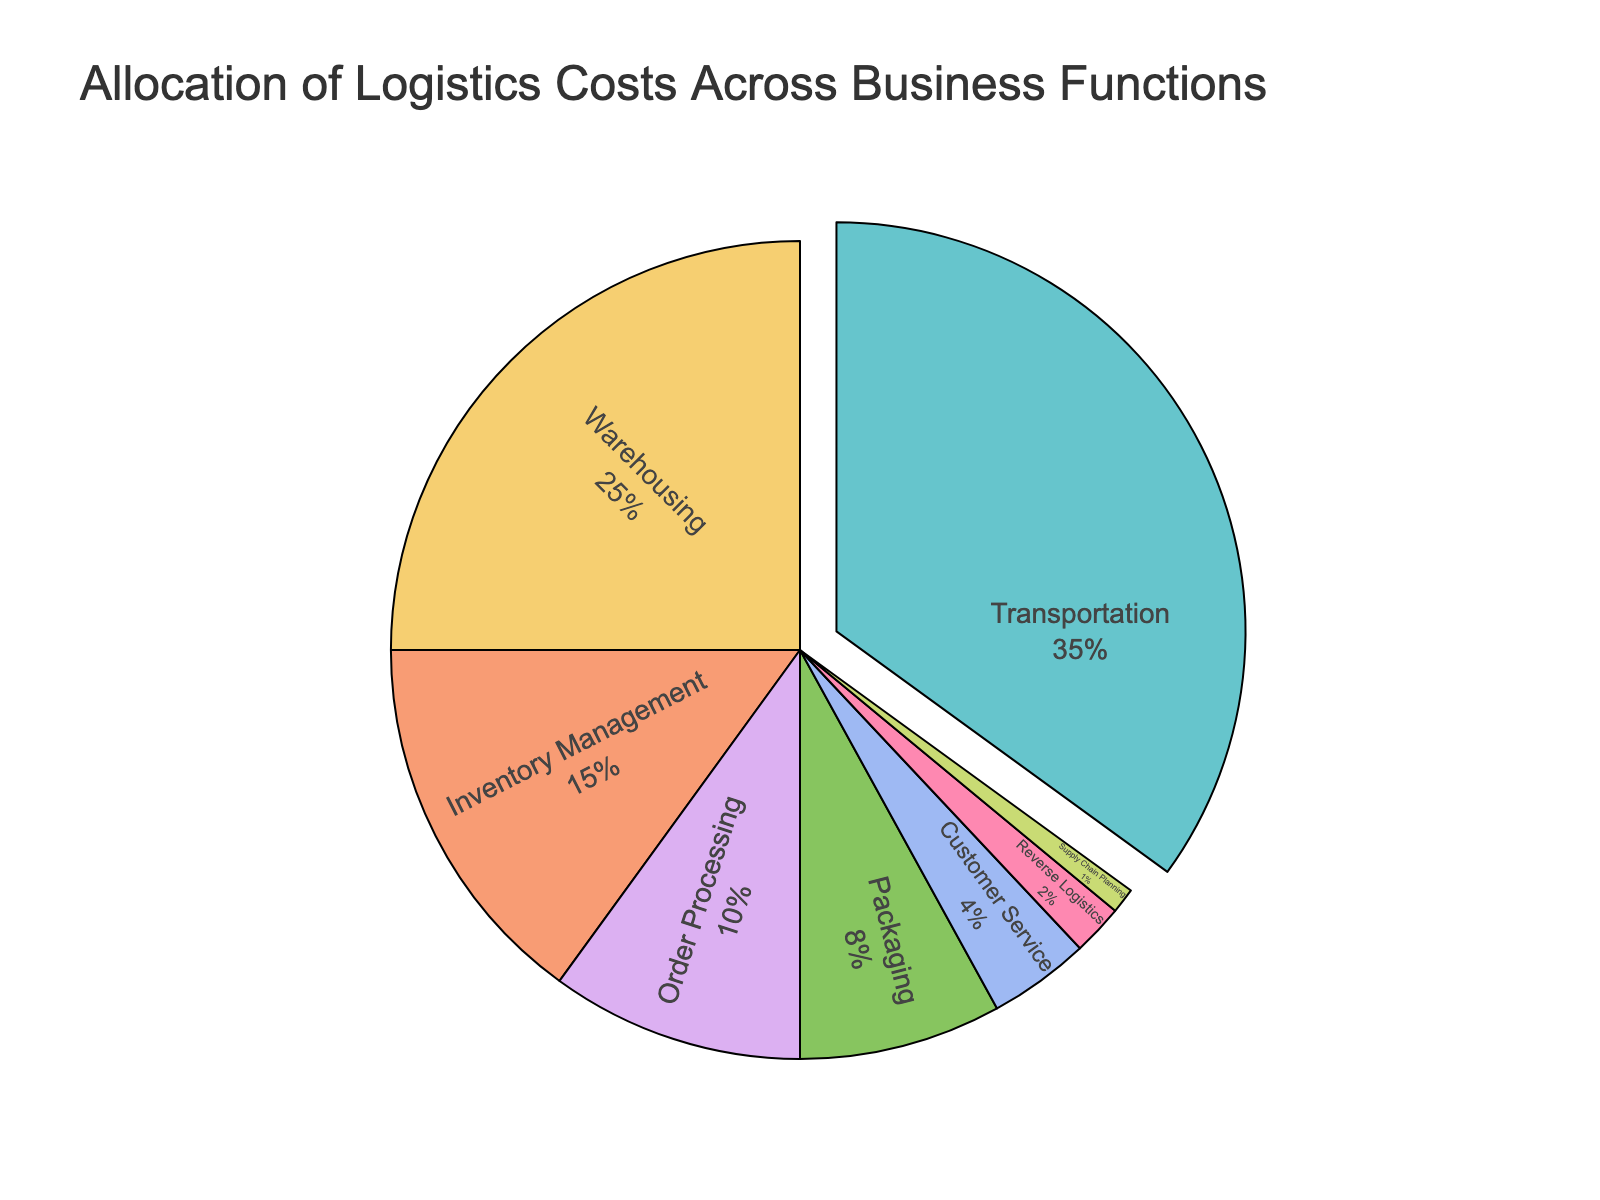What percentage of the total logistics costs is allocated to both Warehousing and Packaging combined? To determine the combined percentage of Warehousing and Packaging, add the individual percentages: Warehousing (25%) + Packaging (8%) = 33%
Answer: 33% Which business function has the highest allocation of logistics costs? By observing the slices of the pie chart, Transportation stands out as it has the largest slice, marked with some separation from the rest. The percentage for Transportation is 35%, which is higher than any other function.
Answer: Transportation How much greater is the cost allocation for Customer Service compared to Reverse Logistics? The cost allocation for Customer Service is 4% and for Reverse Logistics is 2%. The difference can be calculated as: Customer Service (4%) - Reverse Logistics (2%) = 2%
Answer: 2% Is the allocation for Supply Chain Planning more or less than 5%? By referring to the slice labeled Supply Chain Planning, it is clear that it represents only 1% of the logistics costs, which is less than 5%.
Answer: Less What portion of the total logistics costs is accounted for by Inventory Management, Order Processing, and Customer Service together? Adding the percentages for Inventory Management (15%), Order Processing (10%), and Customer Service (4%): 15% + 10% + 4% = 29%
Answer: 29% Which color is used to represent Warehousing in the pie chart? By visually observing the pie chart, the slice corresponding to Warehousing can be identified by its unique color, typically a pastel shade distinct from the others.
Answer: [The actual color might vary based on the specific palette used, e.g., pastel green] How does the percentage allocated to Order Processing compare to that of Reverse Logistics? The percentage for Order Processing is 10%, while Reverse Logistics is 2%. By comparing these values, it is clear that Order Processing has a higher allocation than Reverse Logistics.
Answer: Order Processing is higher If Transportation and Warehousing percentages were combined, what fraction of the total logistics costs would they represent? Adding the percentages for Transportation (35%) and Warehousing (25%) yields a combined percentage of 60%. In fractional terms, this is 60/100, which simplifies to 3/5.
Answer: 3/5 What is the difference in logistics cost allocation between Inventory Management and Packaging? The allocation for Inventory Management is 15% and for Packaging is 8%. The difference between these allocations is calculated as: 15% - 8% = 7%
Answer: 7% Would the combined logistics costs allocation for Customer Service, Reverse Logistics, and Supply Chain Planning exceed 10%? Adding the allocations for Customer Service (4%), Reverse Logistics (2%), and Supply Chain Planning (1%) totals up to: 4% + 2% + 1% = 7%. Since 7% is less than 10%, the combined allocation does not exceed 10%.
Answer: No 